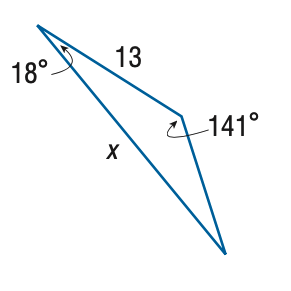Question: Find x. Round the side measure to the nearest tenth.
Choices:
A. 6.4
B. 7.4
C. 22.8
D. 26.5
Answer with the letter. Answer: C 